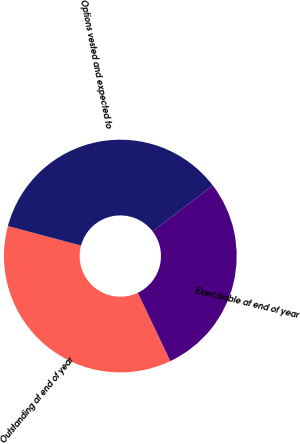Convert chart. <chart><loc_0><loc_0><loc_500><loc_500><pie_chart><fcel>Outstanding at end of year<fcel>Exercisable at end of year<fcel>Options vested and expected to<nl><fcel>36.22%<fcel>28.31%<fcel>35.46%<nl></chart> 